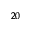<formula> <loc_0><loc_0><loc_500><loc_500>^ { 2 0 }</formula> 